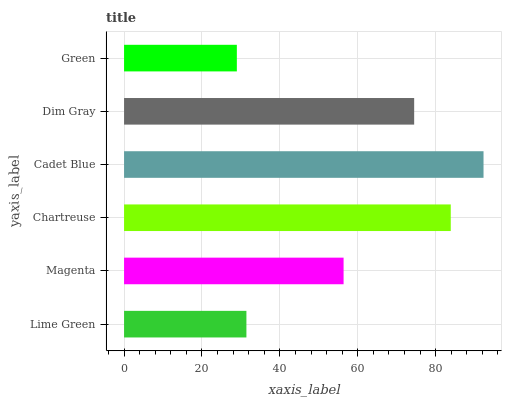Is Green the minimum?
Answer yes or no. Yes. Is Cadet Blue the maximum?
Answer yes or no. Yes. Is Magenta the minimum?
Answer yes or no. No. Is Magenta the maximum?
Answer yes or no. No. Is Magenta greater than Lime Green?
Answer yes or no. Yes. Is Lime Green less than Magenta?
Answer yes or no. Yes. Is Lime Green greater than Magenta?
Answer yes or no. No. Is Magenta less than Lime Green?
Answer yes or no. No. Is Dim Gray the high median?
Answer yes or no. Yes. Is Magenta the low median?
Answer yes or no. Yes. Is Green the high median?
Answer yes or no. No. Is Dim Gray the low median?
Answer yes or no. No. 